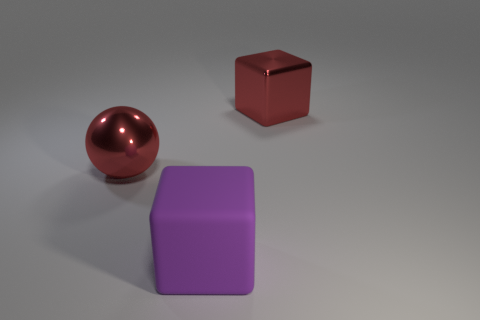The metallic ball has what size?
Offer a terse response. Large. Do the big cube in front of the large red block and the big red sphere have the same material?
Your answer should be very brief. No. There is another shiny object that is the same shape as the purple object; what color is it?
Ensure brevity in your answer.  Red. There is a block that is right of the matte object; does it have the same color as the sphere?
Your answer should be compact. Yes. There is a big red metallic ball; are there any big things behind it?
Keep it short and to the point. Yes. What is the color of the thing that is in front of the large red cube and behind the purple matte cube?
Provide a succinct answer. Red. What shape is the large shiny thing that is the same color as the metal ball?
Your answer should be very brief. Cube. There is a ball in front of the large cube to the right of the big purple matte cube; what is its size?
Provide a succinct answer. Large. What number of cylinders are red metal things or big objects?
Your response must be concise. 0. There is a block that is the same size as the purple object; what color is it?
Make the answer very short. Red. 